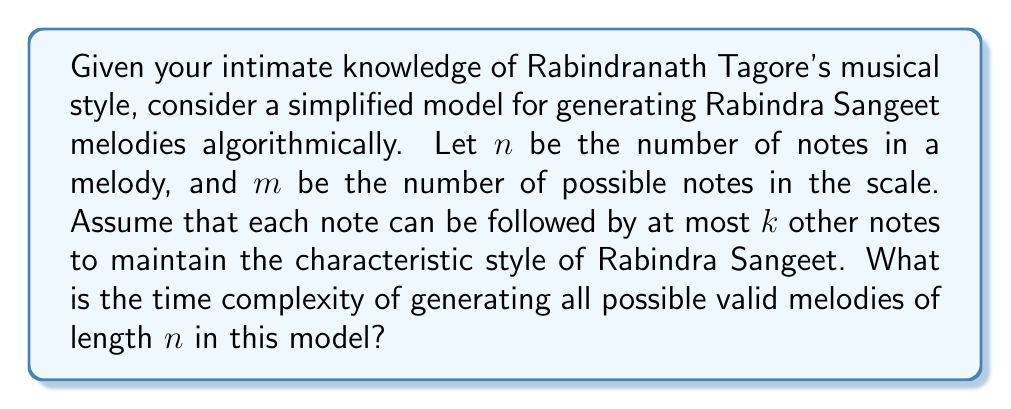Can you answer this question? To solve this problem, let's break it down step by step:

1) First, we need to understand what the question is asking. We're looking at the computational complexity of generating all possible melodies that conform to the rules of Rabindra Sangeet in our simplified model.

2) In this model, we have:
   - $n$: the length of the melody (number of notes)
   - $m$: the total number of possible notes
   - $k$: the maximum number of possible notes that can follow any given note

3) Let's consider how we would generate these melodies:
   - For the first note, we have $m$ choices.
   - For each subsequent note, we have at most $k$ choices.

4) This scenario can be represented as a tree:
   - The root has $m$ children (first note choices)
   - Each subsequent level has at most $k$ children per node

5) The total number of melodies is the number of paths from the root to the leaves in this tree. In the worst case, this is:

   $$m \cdot k^{n-1}$$

6) To generate all these melodies, we need to traverse each path in the tree. The time complexity of generating all melodies is proportional to the number of melodies.

7) Therefore, the time complexity is $O(m \cdot k^{n-1})$.

8) This is an exponential time complexity with respect to $n$, which indicates that the problem becomes computationally hard very quickly as the length of the melody increases.
Answer: The time complexity of generating all possible valid Rabindra Sangeet melodies of length $n$ in this model is $O(m \cdot k^{n-1})$, where $m$ is the number of possible notes and $k$ is the maximum number of notes that can follow any given note. 